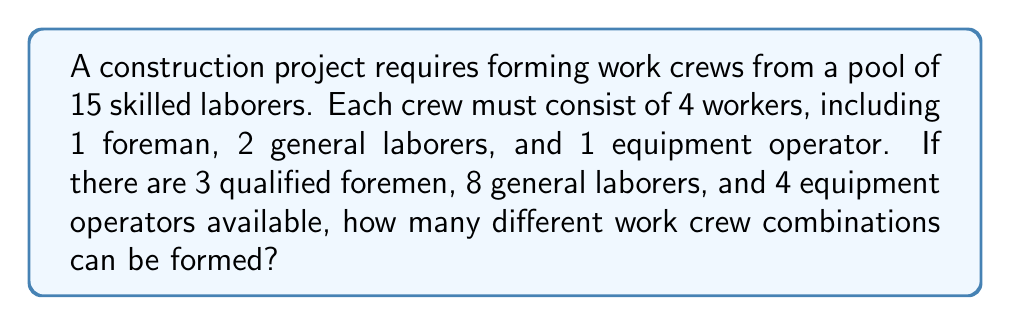Give your solution to this math problem. To solve this problem, we'll use the multiplication principle of counting and combination formulas. Let's break it down step-by-step:

1. Choose a foreman:
   There are 3 qualified foremen, and we need to select 1.
   Number of ways to choose a foreman = $\binom{3}{1} = 3$

2. Choose general laborers:
   There are 8 general laborers, and we need to select 2.
   Number of ways to choose general laborers = $\binom{8}{2} = \frac{8!}{2!(8-2)!} = \frac{8 \cdot 7}{2 \cdot 1} = 28$

3. Choose an equipment operator:
   There are 4 equipment operators, and we need to select 1.
   Number of ways to choose an equipment operator = $\binom{4}{1} = 4$

4. Apply the multiplication principle:
   Total number of possible crew combinations = $3 \cdot 28 \cdot 4 = 336$

Therefore, there are 336 different work crew combinations that can be formed for this construction project.
Answer: 336 